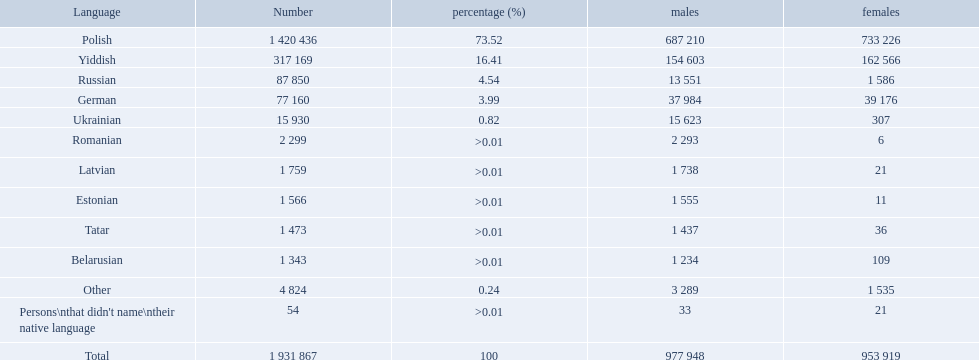What are all of the languages used in the warsaw governorate? Polish, Yiddish, Russian, German, Ukrainian, Romanian, Latvian, Estonian, Tatar, Belarusian, Other, Persons\nthat didn't name\ntheir native language. Which language was comprised of the least number of female speakers? Romanian. What are all the languages? Polish, Yiddish, Russian, German, Ukrainian, Romanian, Latvian, Estonian, Tatar, Belarusian, Other, Persons\nthat didn't name\ntheir native language. Of those languages, which five had fewer than 50 females speaking it? 6, 21, 11, 36, 21. Of those five languages, which is the lowest? Romanian. What are the languages of the warsaw governorate? Polish, Yiddish, Russian, German, Ukrainian, Romanian, Latvian, Estonian, Tatar, Belarusian, Other. What is the percentage of polish? 73.52. What is the next highest amount? 16.41. What is the language with this amount? Yiddish. What is the percentage of polish speakers? 73.52. What is the next highest percentage of speakers? 16.41. What language is this percentage? Yiddish. What were all the languages? Polish, Yiddish, Russian, German, Ukrainian, Romanian, Latvian, Estonian, Tatar, Belarusian, Other, Persons\nthat didn't name\ntheir native language. For these, how many people spoke them? 1 420 436, 317 169, 87 850, 77 160, 15 930, 2 299, 1 759, 1 566, 1 473, 1 343, 4 824, 54. Of these, which is the largest number of speakers? 1 420 436. Which language corresponds to this number? Polish. What are all of the languages Polish, Yiddish, Russian, German, Ukrainian, Romanian, Latvian, Estonian, Tatar, Belarusian, Other, Persons\nthat didn't name\ntheir native language. What was the percentage of each? 73.52, 16.41, 4.54, 3.99, 0.82, >0.01, >0.01, >0.01, >0.01, >0.01, 0.24, >0.01. Which languages had a >0.01	 percentage? Romanian, Latvian, Estonian, Tatar, Belarusian. And of those, which is listed first? Romanian. Which languages had percentages of >0.01? Romanian, Latvian, Estonian, Tatar, Belarusian. What was the top language? Romanian. How many languages are shown? Polish, Yiddish, Russian, German, Ukrainian, Romanian, Latvian, Estonian, Tatar, Belarusian, Other. What language is in third place? Russian. What language is the most spoken after that one? German. Which languages are spoken by more than 50,000 people? Polish, Yiddish, Russian, German. Of these languages, which ones are spoken by less than 15% of the population? Russian, German. Of the remaining two, which one is spoken by 37,984 males? German. Which languages are communicated by greater than 50,000 people? Polish, Yiddish, Russian, German. Of these languages, which ones are expressed by under 15% of the population? Russian, German. Of the remaining two, which one is articulated by 37,984 males? German. What were all the dialects? Polish, Yiddish, Russian, German, Ukrainian, Romanian, Latvian, Estonian, Tatar, Belarusian, Other, Persons\nthat didn't name\ntheir native language. For these, how many individuals communicated in them? 1 420 436, 317 169, 87 850, 77 160, 15 930, 2 299, 1 759, 1 566, 1 473, 1 343, 4 824, 54. Of these, which has the highest quantity of speakers? 1 420 436. Which dialect corresponds to this figure? Polish. What languages were utilized in the warsaw governorate? Polish, Yiddish, Russian, German, Ukrainian, Romanian, Latvian, Estonian, Tatar, Belarusian, Other, Persons\nthat didn't name\ntheir native language. Which language contained the fewest female speakers? Romanian. How many languages are exhibited? Polish, Yiddish, Russian, German, Ukrainian, Romanian, Latvian, Estonian, Tatar, Belarusian, Other. What language holds the third rank? Russian. What language has the highest number of speakers after that one? German. What languages are spoken in the warsaw governorate? Polish, Yiddish, Russian, German, Ukrainian, Romanian, Latvian, Estonian, Tatar, Belarusian, Other. What is the ratio of polish speakers? 73.52. What is the following highest proportion? 16.41. What language has this proportion? Yiddish. What languages are spoken in the warsaw governorate? Polish, Yiddish, Russian, German, Ukrainian, Romanian, Latvian, Estonian, Tatar, Belarusian. Which are the top five languages? Polish, Yiddish, Russian, German, Ukrainian. Of those, which is the second most commonly spoken? Yiddish. What is the total number of languages in existence? Polish, Yiddish, Russian, German, Ukrainian, Romanian, Latvian, Estonian, Tatar, Belarusian. Which one is spoken by the largest population? Polish. In which languages was the percentage more than 0.01? Romanian, Latvian, Estonian, Tatar, Belarusian. What language was at the top? Romanian. What languages exceeded 0.01 in percentage? Romanian, Latvian, Estonian, Tatar, Belarusian. Which language took the top position? Romanian. In the warsaw governorate, what languages are being spoken? Polish, Yiddish, Russian, German, Ukrainian, Romanian, Latvian, Estonian, Tatar, Belarusian, Other, Persons\nthat didn't name\ntheir native language. What is the total for russian speakers? 87 850. Which number is directly above the lowest on the list? 77 160. What language is spoken by a total of 77,160 people? German. 